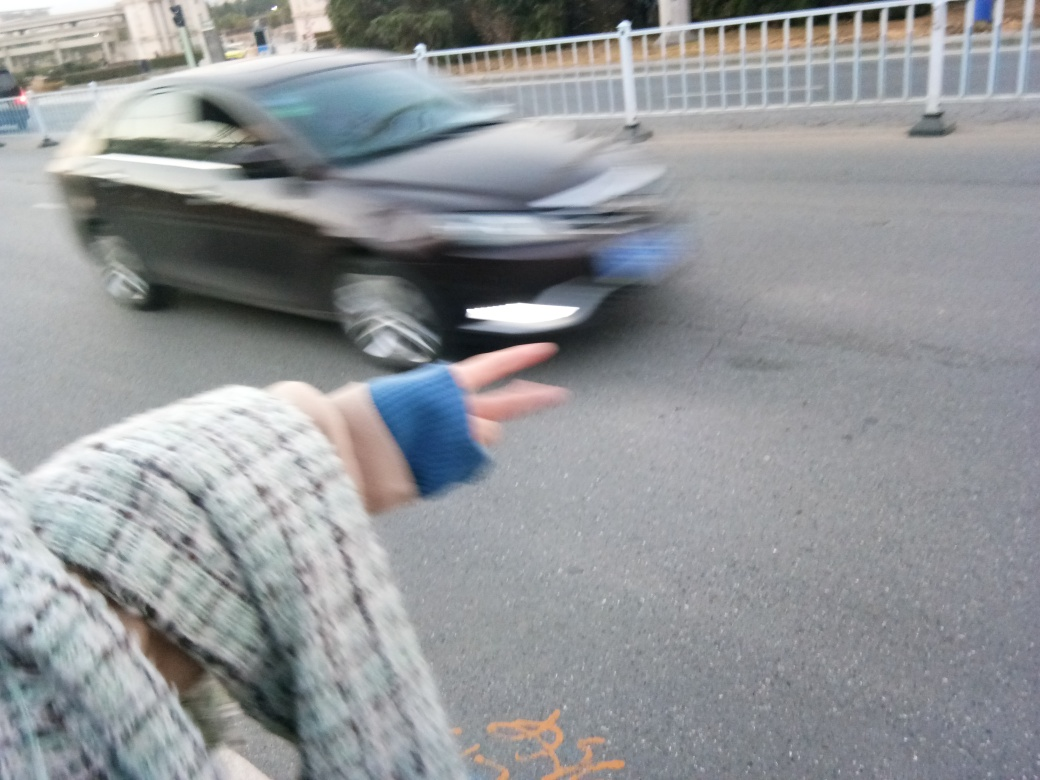Is there anything that can be deduced about the time of day? The lighting in the image is diffused, without harsh shadows or bright sunlight, which might suggest the photo was taken either on an overcast day or during the times of day when the sun is lower in the sky, such as in the early morning or late afternoon. The relative absence of long shadows could indicate that the sun is not at a low angle, which might rule out sunrise or sunset times, leaning towards an overcast day scenario. 